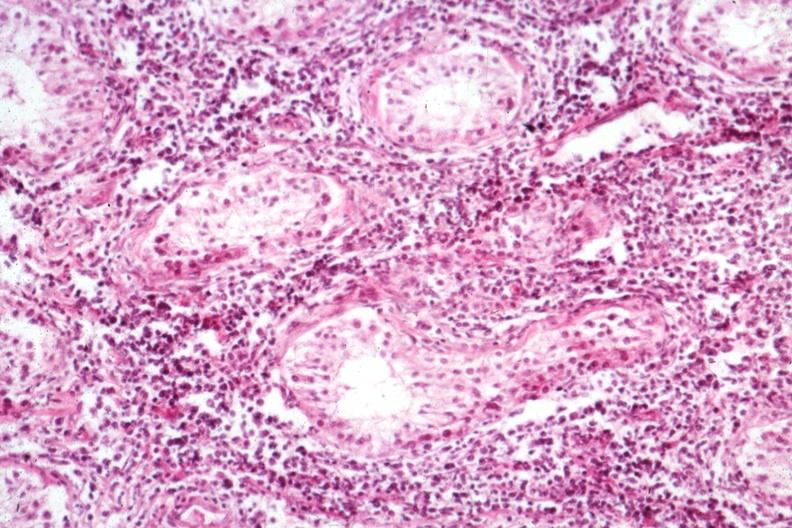what does this image show?
Answer the question using a single word or phrase. Interstitial infiltrate well shown not the best morphology 